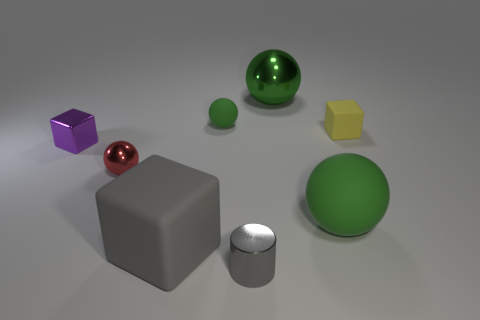There is a metallic ball that is the same size as the yellow rubber thing; what color is it?
Ensure brevity in your answer.  Red. How many other objects are there of the same shape as the gray metal thing?
Keep it short and to the point. 0. Are there any big spheres that have the same material as the large block?
Offer a very short reply. Yes. Is the ball that is left of the small green rubber ball made of the same material as the large green object behind the metallic block?
Your answer should be compact. Yes. How many tiny green balls are there?
Your response must be concise. 1. What shape is the large green thing that is behind the purple thing?
Make the answer very short. Sphere. What number of other things are the same size as the purple object?
Your response must be concise. 4. Is the shape of the tiny matte object in front of the tiny matte ball the same as the big matte object behind the big matte block?
Ensure brevity in your answer.  No. There is a yellow block; what number of green metal balls are to the left of it?
Provide a succinct answer. 1. The tiny shiny thing that is left of the tiny red object is what color?
Offer a very short reply. Purple. 